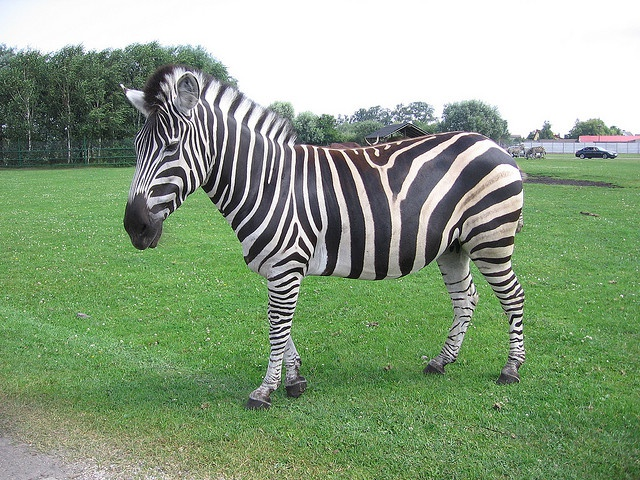Describe the objects in this image and their specific colors. I can see zebra in lavender, gray, lightgray, black, and darkgray tones and car in lavender, black, navy, and gray tones in this image. 